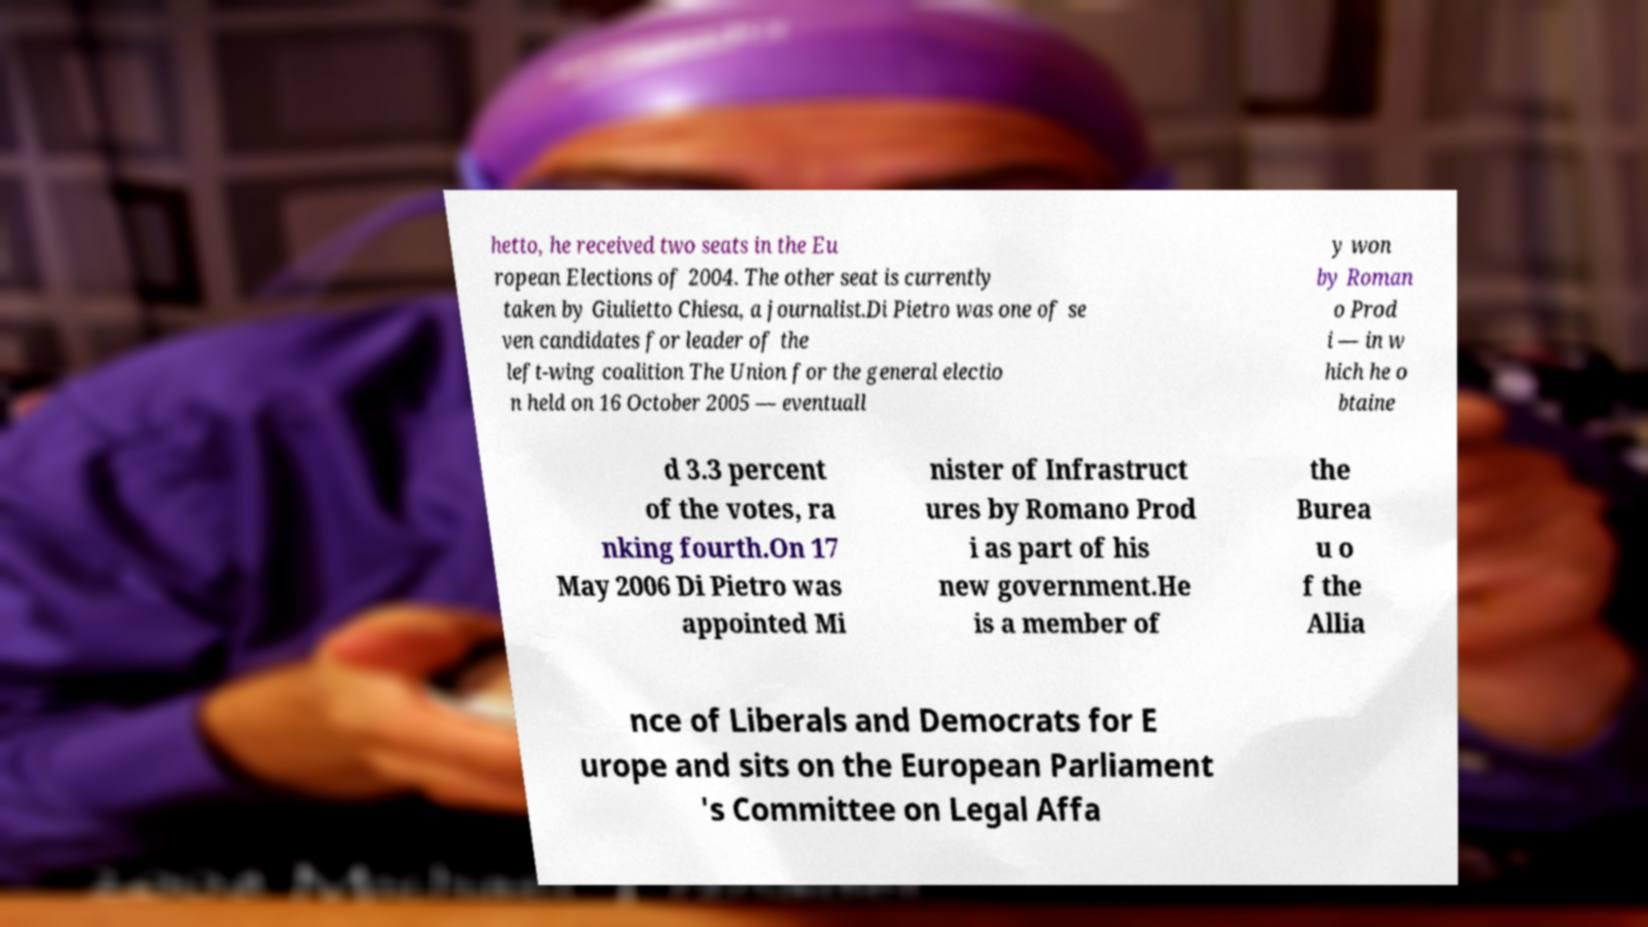There's text embedded in this image that I need extracted. Can you transcribe it verbatim? hetto, he received two seats in the Eu ropean Elections of 2004. The other seat is currently taken by Giulietto Chiesa, a journalist.Di Pietro was one of se ven candidates for leader of the left-wing coalition The Union for the general electio n held on 16 October 2005 — eventuall y won by Roman o Prod i — in w hich he o btaine d 3.3 percent of the votes, ra nking fourth.On 17 May 2006 Di Pietro was appointed Mi nister of Infrastruct ures by Romano Prod i as part of his new government.He is a member of the Burea u o f the Allia nce of Liberals and Democrats for E urope and sits on the European Parliament 's Committee on Legal Affa 